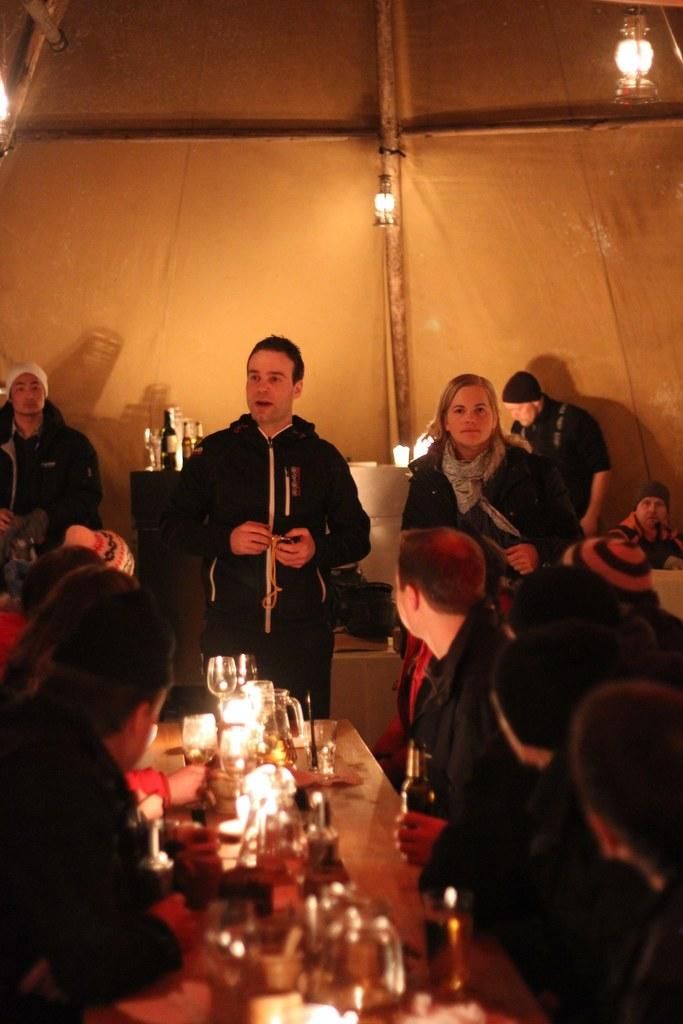How many people are in the image? There are many people in the image. What are the people wearing? The people are wearing clothes. Can you describe the table in the image? There is a table in the image, and it has a light and a wine glass on it. What else is on the table? There is also a bottle on the table. What other object can be seen in the image? There is a wooden pole in the image. Where is the baby sitting in the image? There is no baby present in the image. What color is the spot on the roof in the image? There is no spot on the roof in the image, as there is no mention of a roof in the provided facts. 